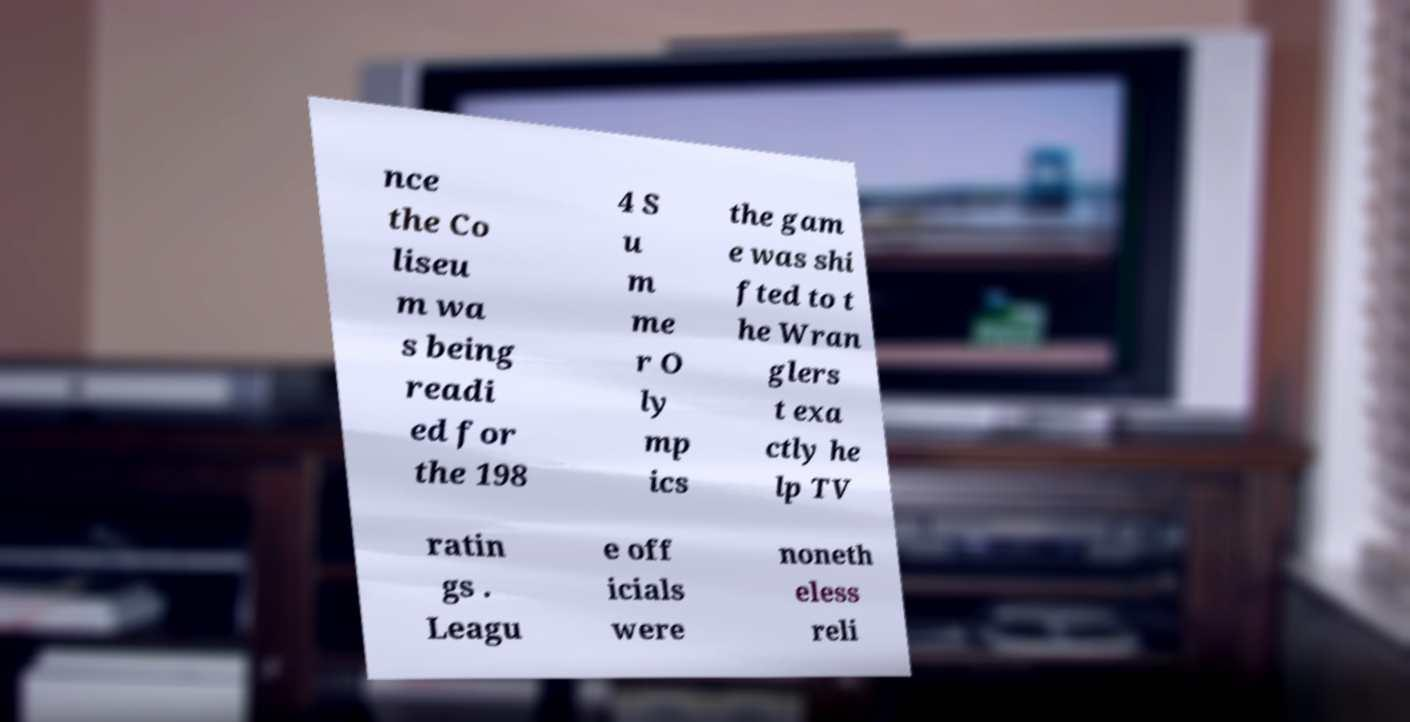What messages or text are displayed in this image? I need them in a readable, typed format. nce the Co liseu m wa s being readi ed for the 198 4 S u m me r O ly mp ics the gam e was shi fted to t he Wran glers t exa ctly he lp TV ratin gs . Leagu e off icials were noneth eless reli 